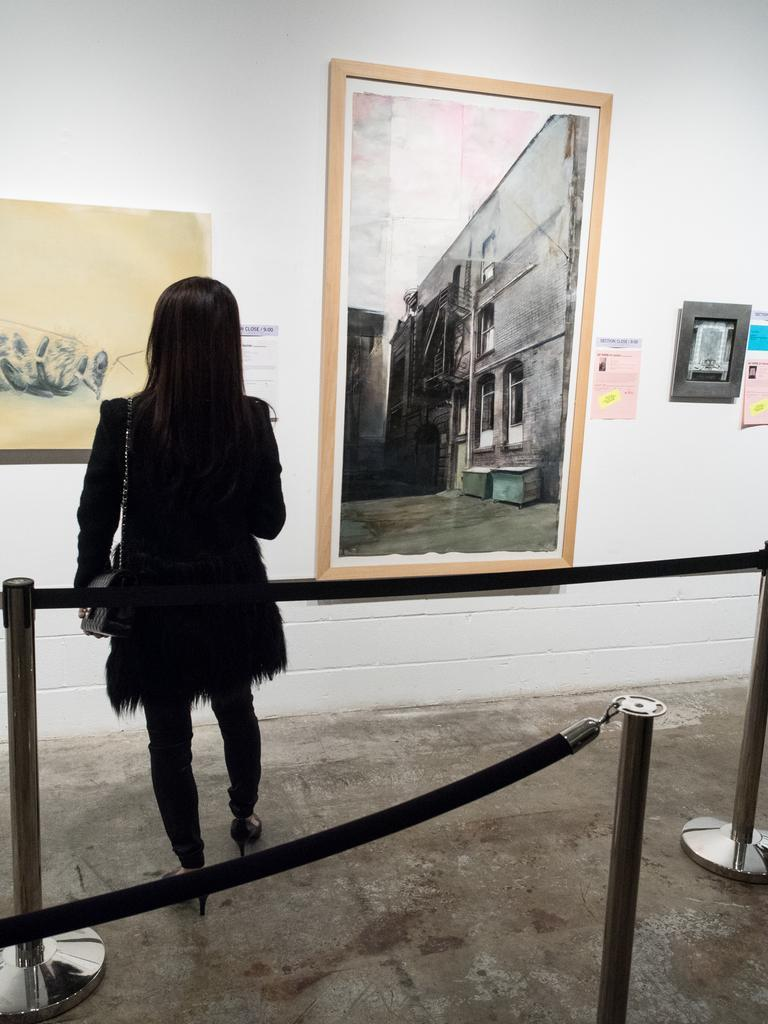What objects are arranged from left to right in the image? There are rods and ropes arranged from left to right in the image. What is the woman in the image wearing? The woman is wearing a bag. Where is the woman standing in the image? The woman is standing on the ground. What can be seen on the wall in the image? There are frames and posters on the wall in the image. What type of instrument is the woman playing in the image? There is no instrument present in the image, and the woman is not playing any instrument. Is there a plantation visible in the image? No, there is no plantation visible in the image. 